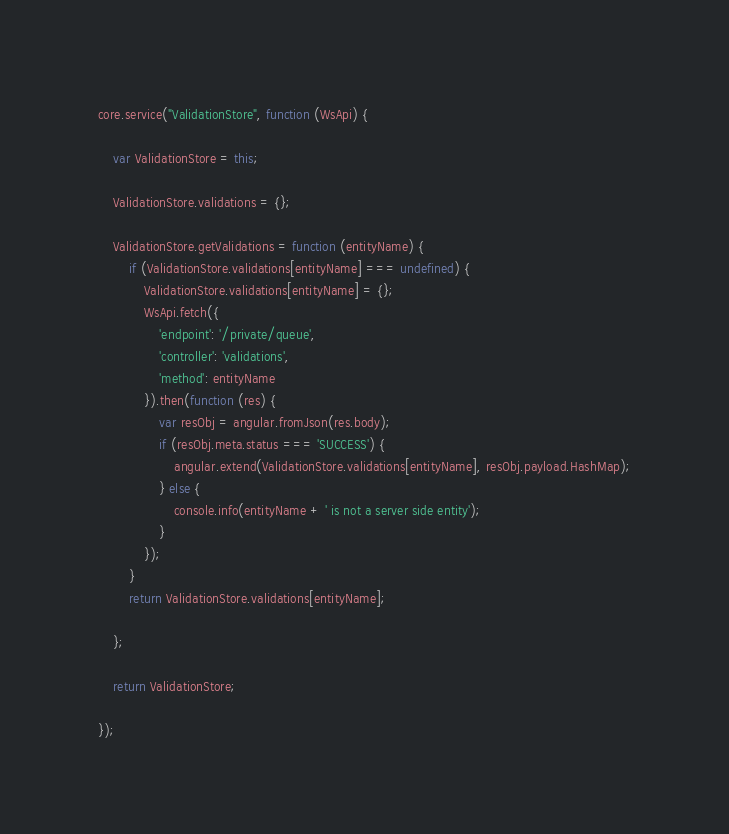Convert code to text. <code><loc_0><loc_0><loc_500><loc_500><_JavaScript_>core.service("ValidationStore", function (WsApi) {

    var ValidationStore = this;

    ValidationStore.validations = {};

    ValidationStore.getValidations = function (entityName) {
        if (ValidationStore.validations[entityName] === undefined) {
            ValidationStore.validations[entityName] = {};
            WsApi.fetch({
                'endpoint': '/private/queue',
                'controller': 'validations',
                'method': entityName
            }).then(function (res) {
                var resObj = angular.fromJson(res.body);
                if (resObj.meta.status === 'SUCCESS') {
                    angular.extend(ValidationStore.validations[entityName], resObj.payload.HashMap);
                } else {
                    console.info(entityName + ' is not a server side entity');
                }
            });
        }
        return ValidationStore.validations[entityName];

    };

    return ValidationStore;

});
</code> 